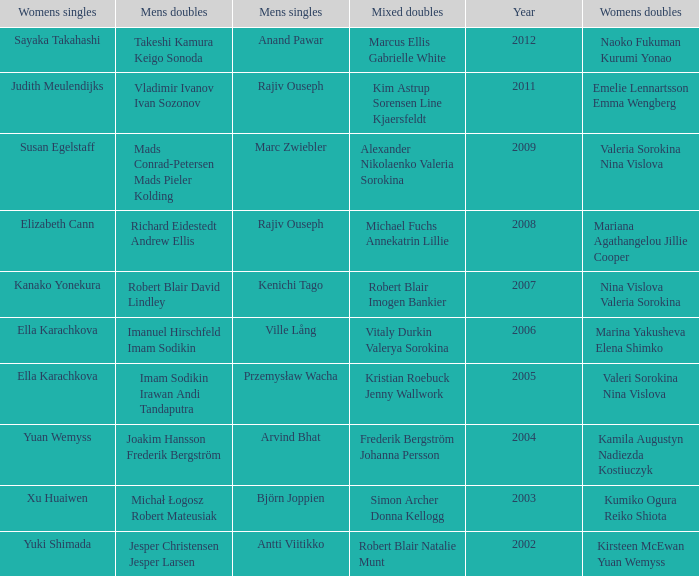What are the womens singles of naoko fukuman kurumi yonao? Sayaka Takahashi. 